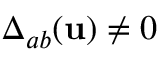<formula> <loc_0><loc_0><loc_500><loc_500>\Delta _ { a b } ( { u } ) \neq 0</formula> 